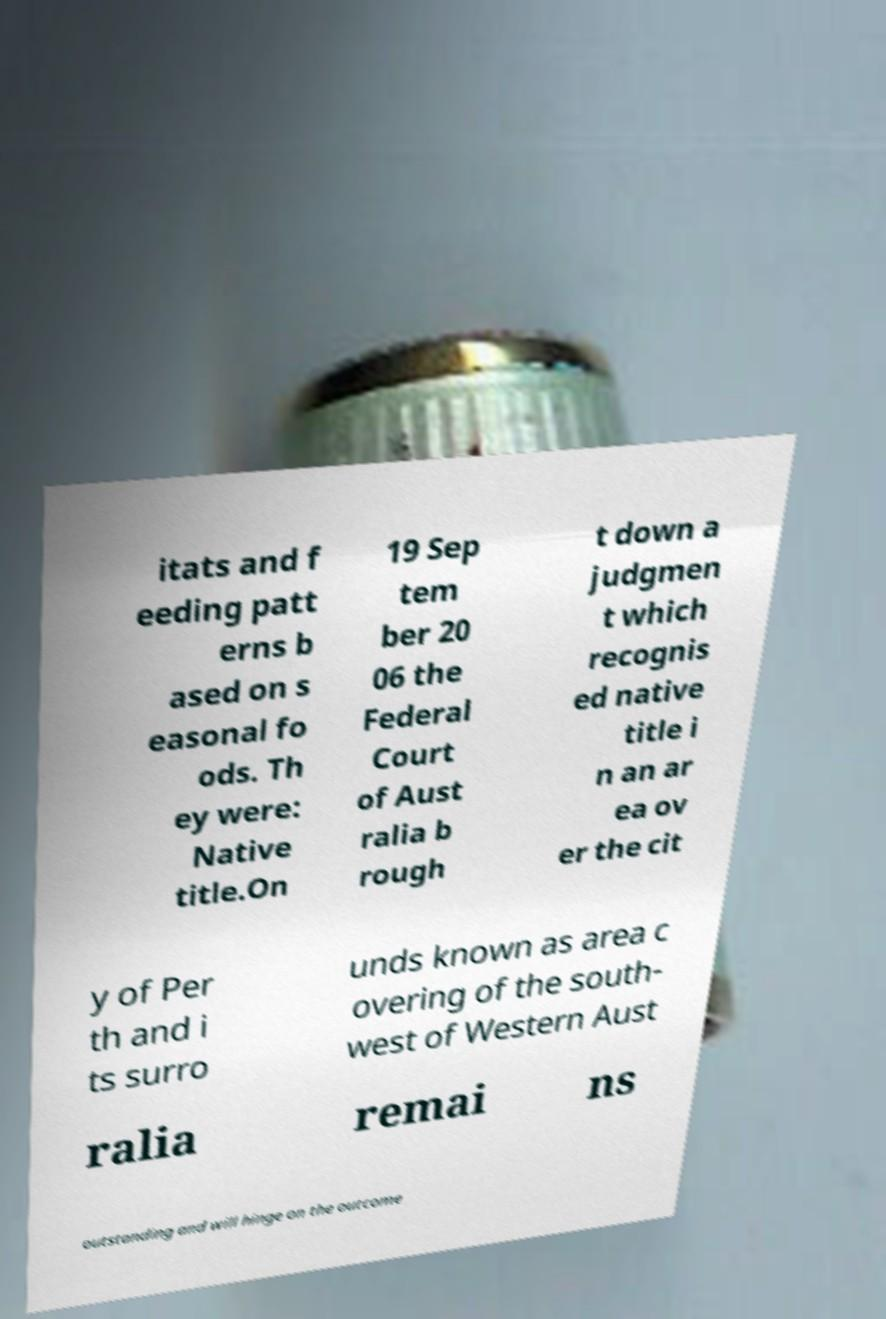What messages or text are displayed in this image? I need them in a readable, typed format. itats and f eeding patt erns b ased on s easonal fo ods. Th ey were: Native title.On 19 Sep tem ber 20 06 the Federal Court of Aust ralia b rough t down a judgmen t which recognis ed native title i n an ar ea ov er the cit y of Per th and i ts surro unds known as area c overing of the south- west of Western Aust ralia remai ns outstanding and will hinge on the outcome 